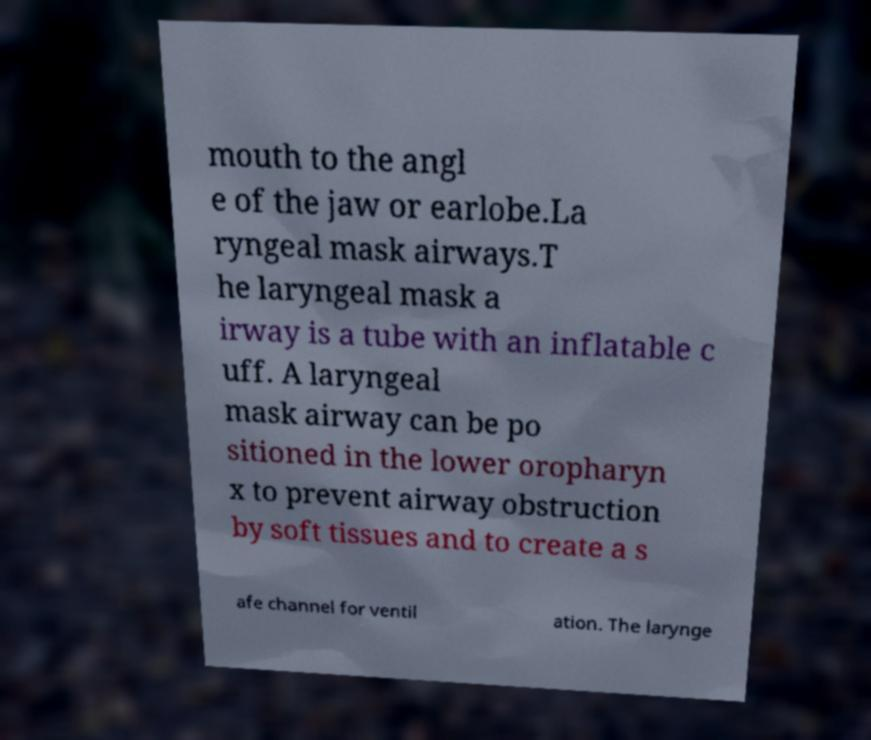Could you assist in decoding the text presented in this image and type it out clearly? mouth to the angl e of the jaw or earlobe.La ryngeal mask airways.T he laryngeal mask a irway is a tube with an inflatable c uff. A laryngeal mask airway can be po sitioned in the lower oropharyn x to prevent airway obstruction by soft tissues and to create a s afe channel for ventil ation. The larynge 